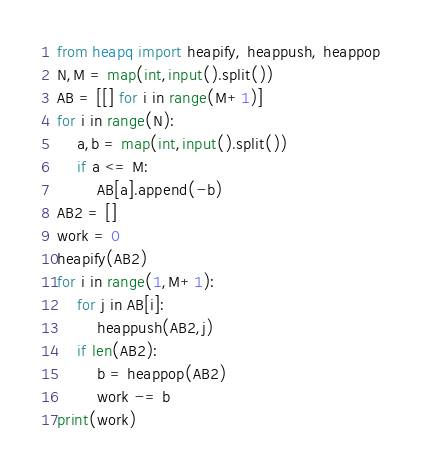<code> <loc_0><loc_0><loc_500><loc_500><_Python_>from heapq import heapify, heappush, heappop
N,M = map(int,input().split())
AB = [[] for i in range(M+1)]
for i in range(N):
    a,b = map(int,input().split())
    if a <= M:
        AB[a].append(-b)
AB2 = []
work = 0
heapify(AB2)
for i in range(1,M+1):
    for j in AB[i]:
        heappush(AB2,j)
    if len(AB2):
        b = heappop(AB2)
        work -= b
print(work)</code> 